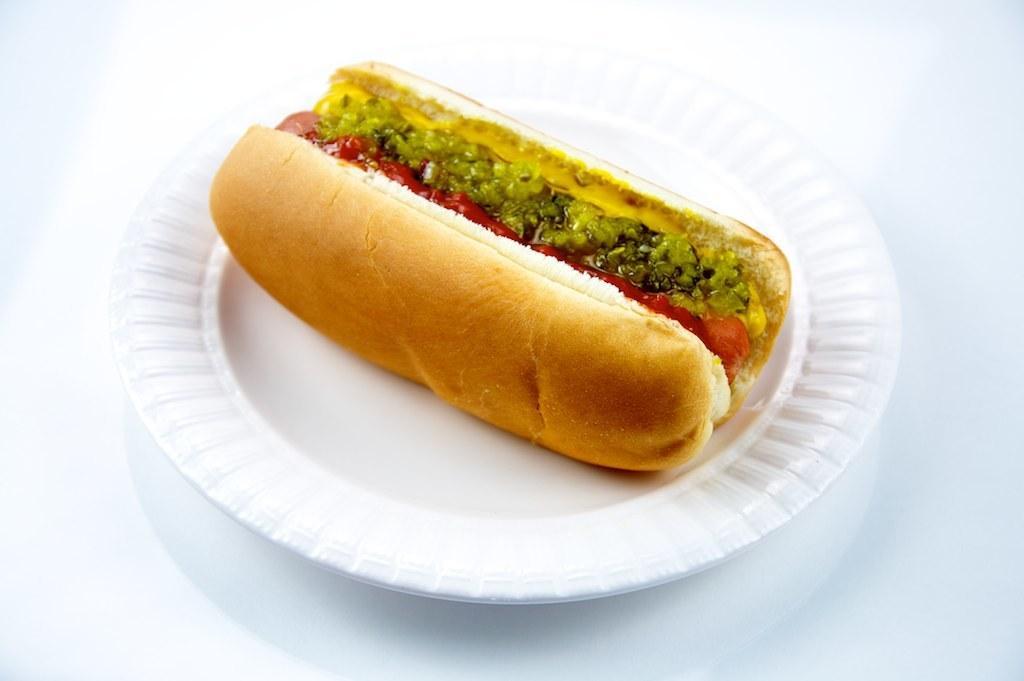In one or two sentences, can you explain what this image depicts? On the white plate we can see a burger. On the bottom there is a table. 